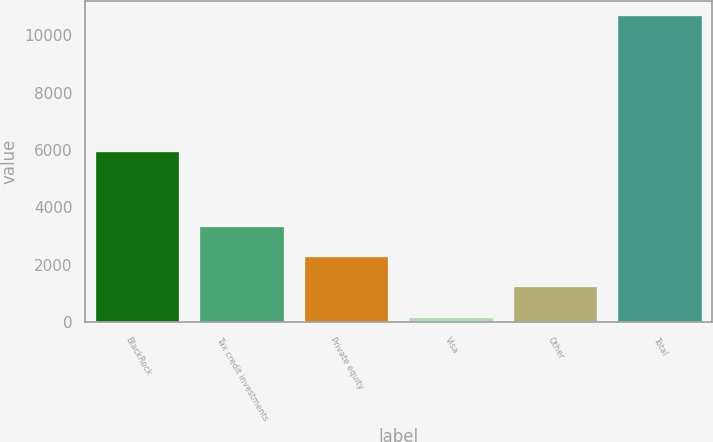<chart> <loc_0><loc_0><loc_500><loc_500><bar_chart><fcel>BlackRock<fcel>Tax credit investments<fcel>Private equity<fcel>Visa<fcel>Other<fcel>Total<nl><fcel>5940<fcel>3309.8<fcel>2259.2<fcel>158<fcel>1208.6<fcel>10664<nl></chart> 